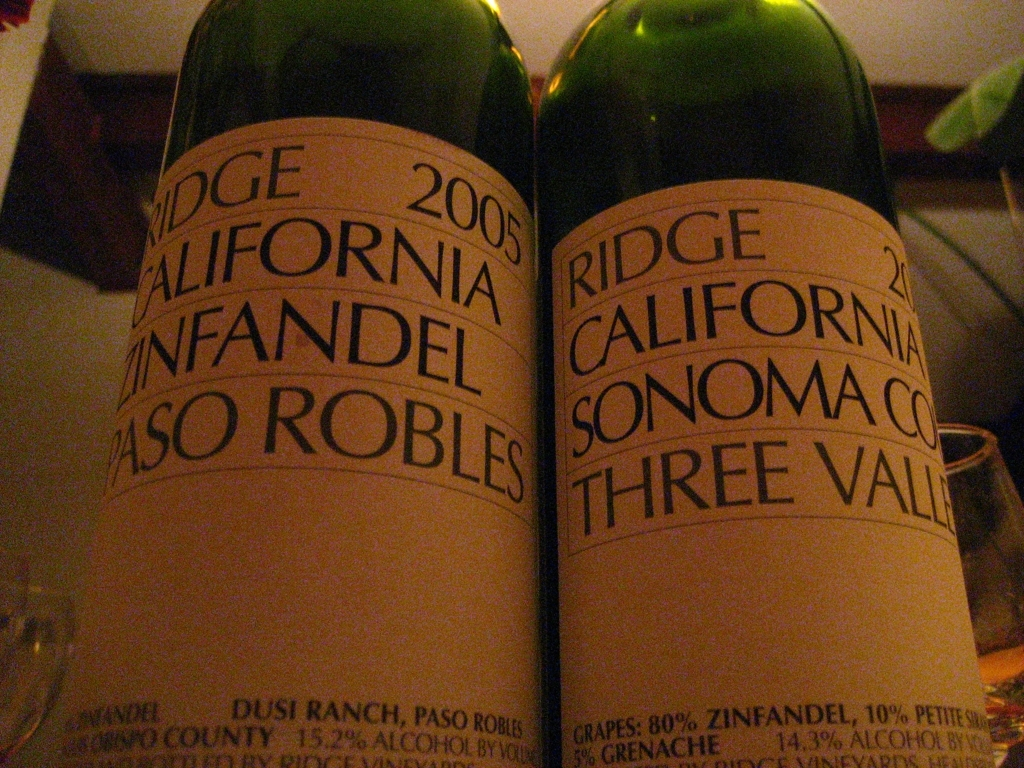Is the background heavily blurred? Yes, the background is indeed heavily blurred, which places a stronger emphasis on the two wine bottles in the foreground, capturing the viewer's attention on the labels and details of the bottles. 